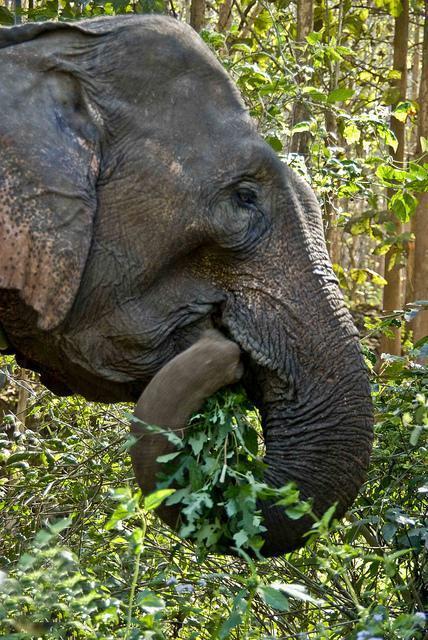How many ears does the giraffe have?
Give a very brief answer. 0. 